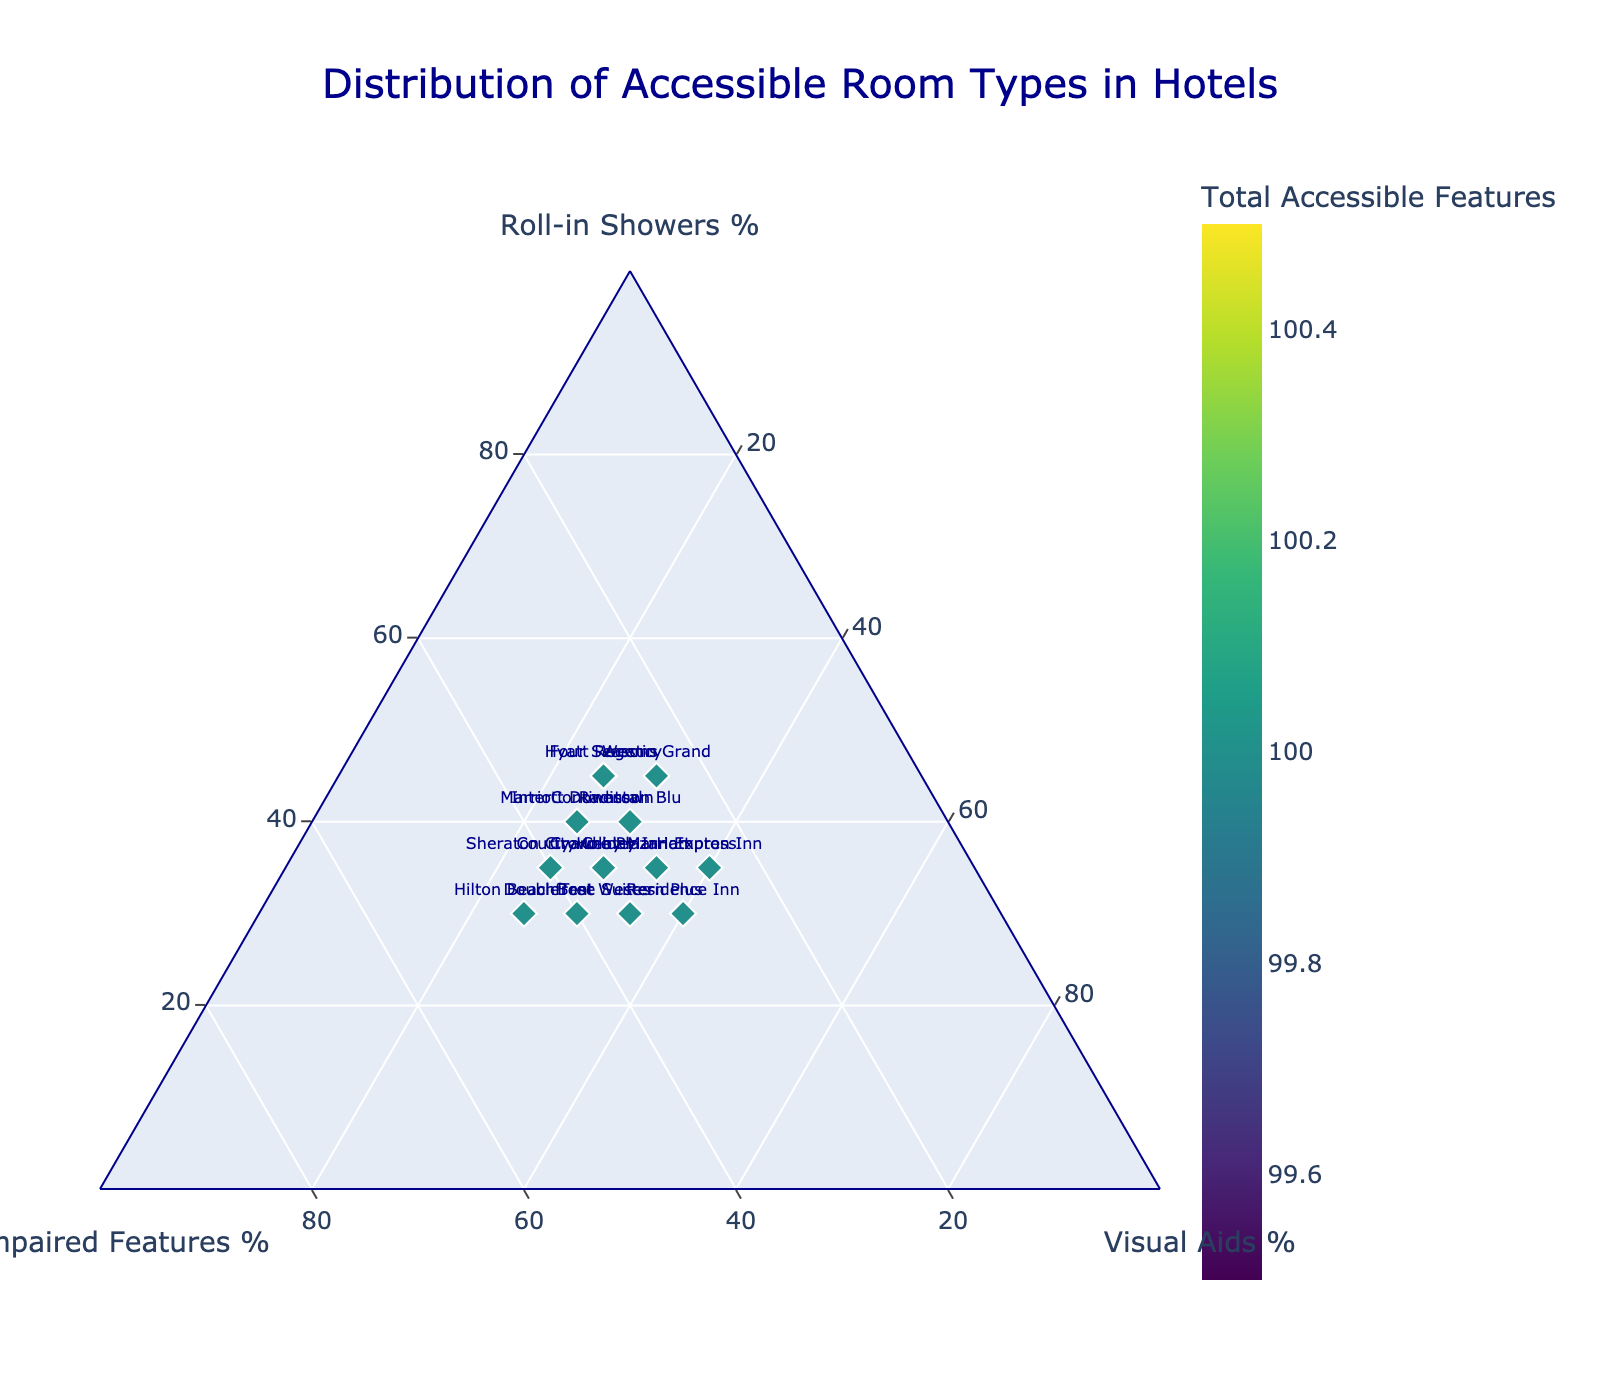What is the title of the figure? The title of the figure is displayed at the top and describes the purpose of the ternary plot.
Answer: Distribution of Accessible Room Types in Hotels How many hotels are represented in the scatter plot? Each hotel is represented by a unique marker on the ternary plot. By counting these markers, you can determine the total number of hotels.
Answer: 15 Which hotel has the highest percentage of roll-in showers? Locate the marker with the highest value on the Roll-in Showers % axis. This marker belongs to the hotel with the highest percentage of roll-in showers.
Answer: Hyatt Regency How does the distribution of the Courtyard by Marriott compare to the DoubleTree Suites in terms of visual aids? Find the markers for Courtyard by Marriott and DoubleTree Suites, and compare their positions along the Visual Aids % axis.
Answer: Both have 30% visual aids Which hotel has the most balanced distribution among the three types of accessible features? A balanced distribution means the marker is closer to the center of the ternary plot, suggesting equal proportions of the features.
Answer: Holiday Inn Express What is the total number of accessible features for the Westin Grand? The color intensity of the marker indicates the total number of accessible features. Check the figure’s color scale and find the value for Westin Grand.
Answer: 100 What is the approximate percentage of hearing-impaired features for Hilton Beachfront? Locate Hilton Beachfront's marker and read the approximate percentage from the Hearing-Impaired Features % axis.
Answer: 45% Which hotel has the lowest percentage of visual aids? From the Visual Aids % axis, identify the marker with the lowest value. This corresponds to the hotel with the lowest percentage of visual aids.
Answer: Westin Grand Which two hotels have the same total number of accessible features but different distributions? To find markers with the same color intensity (indicating the same total number of accessible features), check for variations in their positions within the ternary plot.
Answer: InterContinental and Marriott Downtown Is there a trend or pattern visible in the distribution of accessible room types among the hotels? Analyze the overall position of the markers in the ternary plot to identify any visible trends or clustering patterns among the accessible room types.
Answer: No clear trend 